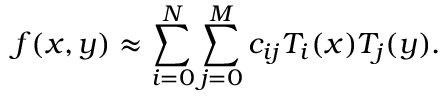Convert formula to latex. <formula><loc_0><loc_0><loc_500><loc_500>f ( x , y ) \approx \sum _ { i = 0 } ^ { N } \sum _ { j = 0 } ^ { M } c _ { i j } T _ { i } ( x ) T _ { j } ( y ) .</formula> 